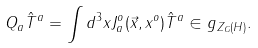<formula> <loc_0><loc_0><loc_500><loc_500>Q _ { a } { \hat { T } } ^ { a } = \int d ^ { 3 } x J _ { a } ^ { o } ( \vec { x } , x ^ { o } ) { \hat { T } } ^ { a } \in g _ { Z _ { G } ( H ) } .</formula> 